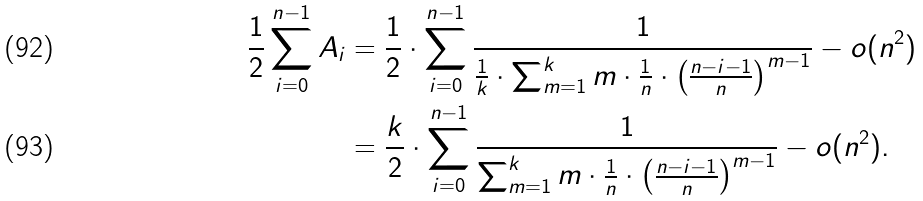Convert formula to latex. <formula><loc_0><loc_0><loc_500><loc_500>\frac { 1 } { 2 } \sum _ { i = 0 } ^ { n - 1 } A _ { i } & = \frac { 1 } { 2 } \cdot \sum _ { i = 0 } ^ { n - 1 } \frac { 1 } { \frac { 1 } { k } \cdot \sum _ { m = 1 } ^ { k } m \cdot \frac { 1 } { n } \cdot \left ( \frac { n - i - 1 } { n } \right ) ^ { m - 1 } } - o ( n ^ { 2 } ) \\ & = \frac { k } { 2 } \cdot \sum _ { i = 0 } ^ { n - 1 } \frac { 1 } { \sum _ { m = 1 } ^ { k } m \cdot \frac { 1 } { n } \cdot \left ( \frac { n - i - 1 } { n } \right ) ^ { m - 1 } } - o ( n ^ { 2 } ) .</formula> 